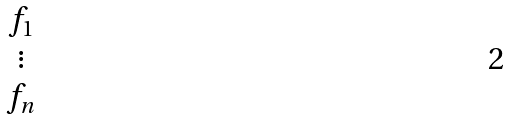<formula> <loc_0><loc_0><loc_500><loc_500>\begin{matrix} f _ { 1 } \\ \vdots \\ f _ { n } \end{matrix}</formula> 